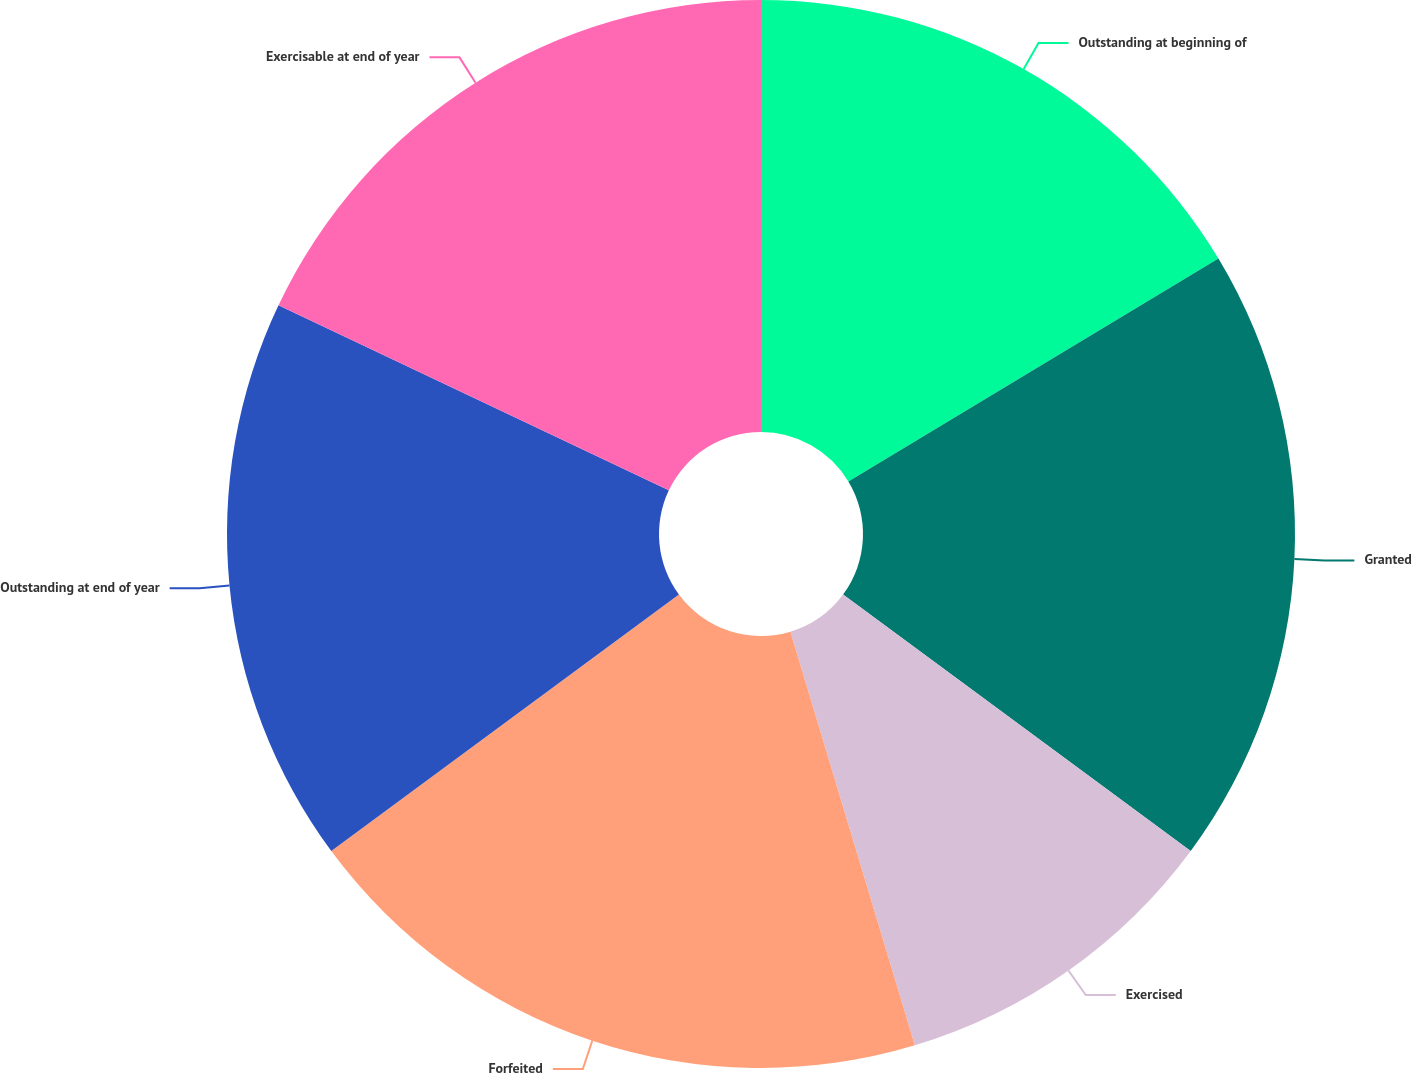Convert chart to OTSL. <chart><loc_0><loc_0><loc_500><loc_500><pie_chart><fcel>Outstanding at beginning of<fcel>Granted<fcel>Exercised<fcel>Forfeited<fcel>Outstanding at end of year<fcel>Exercisable at end of year<nl><fcel>16.37%<fcel>18.74%<fcel>10.23%<fcel>19.53%<fcel>17.16%<fcel>17.95%<nl></chart> 